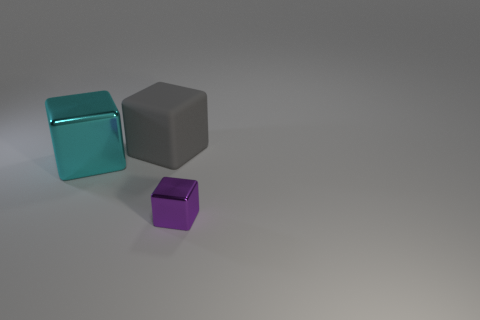Subtract all cyan cubes. Subtract all blue cylinders. How many cubes are left? 2 Add 2 cyan metal things. How many objects exist? 5 Add 2 big gray rubber cubes. How many big gray rubber cubes are left? 3 Add 3 purple metal blocks. How many purple metal blocks exist? 4 Subtract 0 green spheres. How many objects are left? 3 Subtract all big rubber blocks. Subtract all small purple objects. How many objects are left? 1 